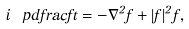<formula> <loc_0><loc_0><loc_500><loc_500>i \ p d f r a c { f } { t } = - \nabla ^ { 2 } f + | f | ^ { 2 } f ,</formula> 